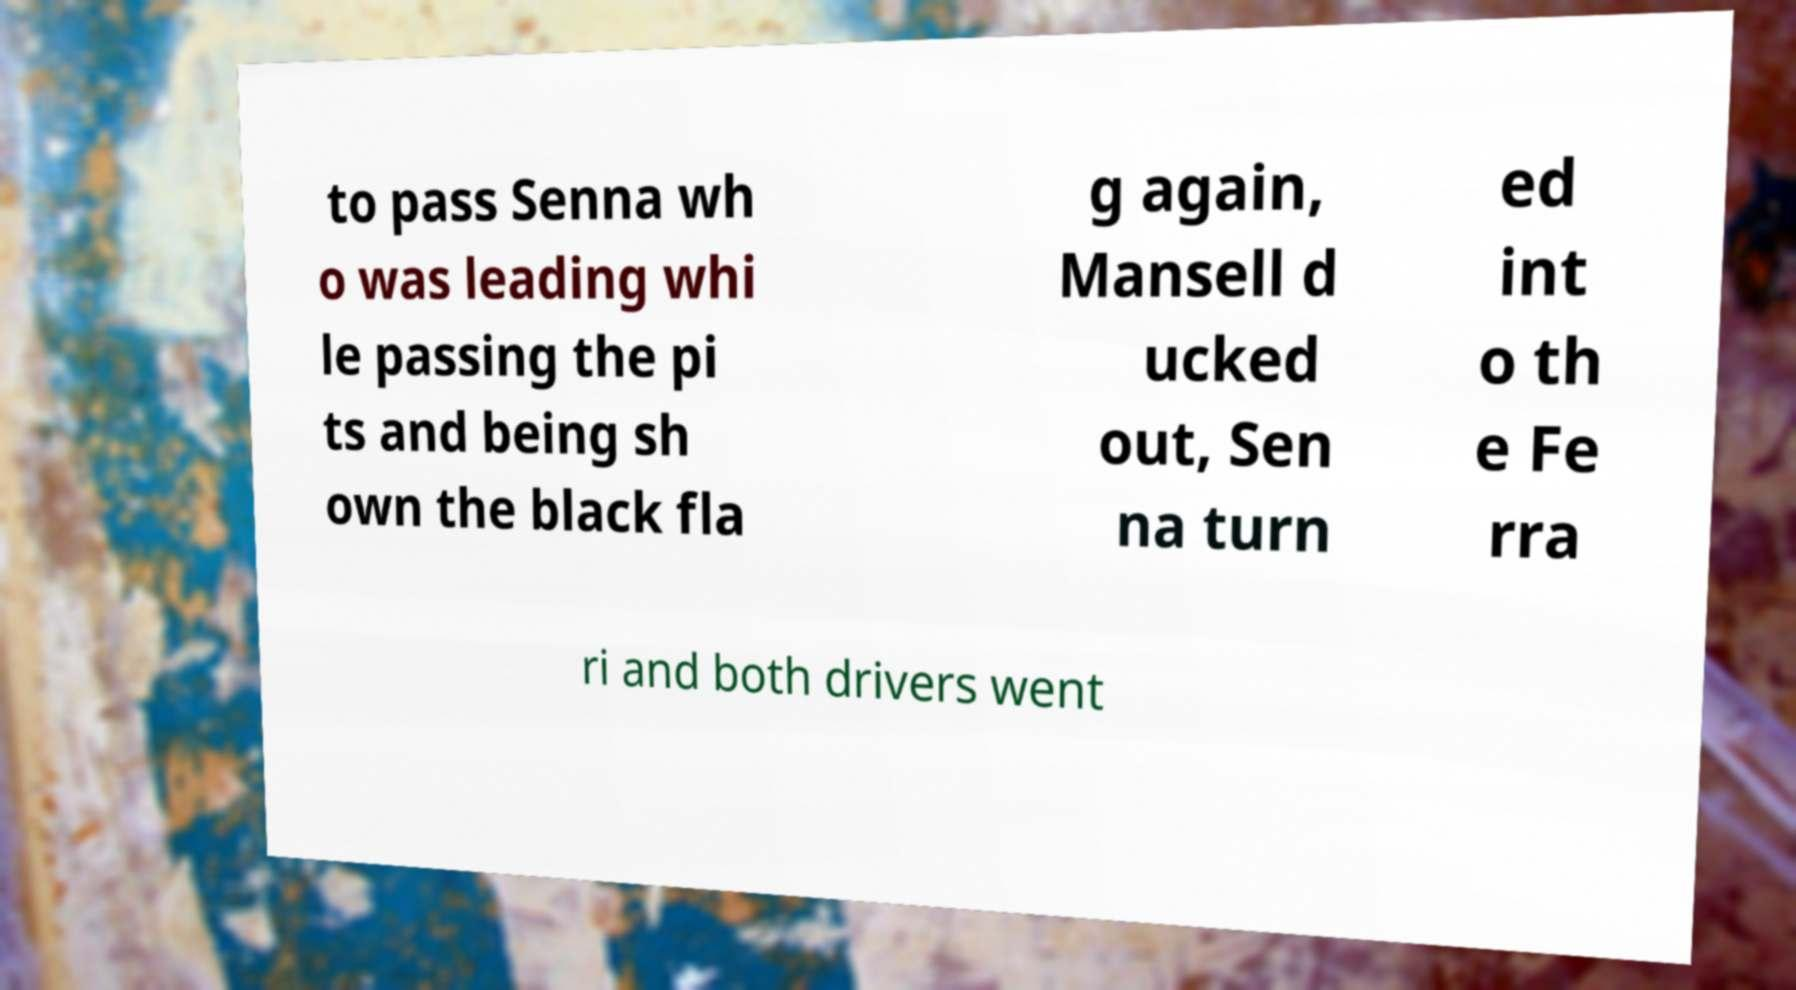Could you assist in decoding the text presented in this image and type it out clearly? to pass Senna wh o was leading whi le passing the pi ts and being sh own the black fla g again, Mansell d ucked out, Sen na turn ed int o th e Fe rra ri and both drivers went 